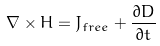Convert formula to latex. <formula><loc_0><loc_0><loc_500><loc_500>\nabla \times H = J _ { f r e e } + { \frac { \partial D } { \partial t } }</formula> 